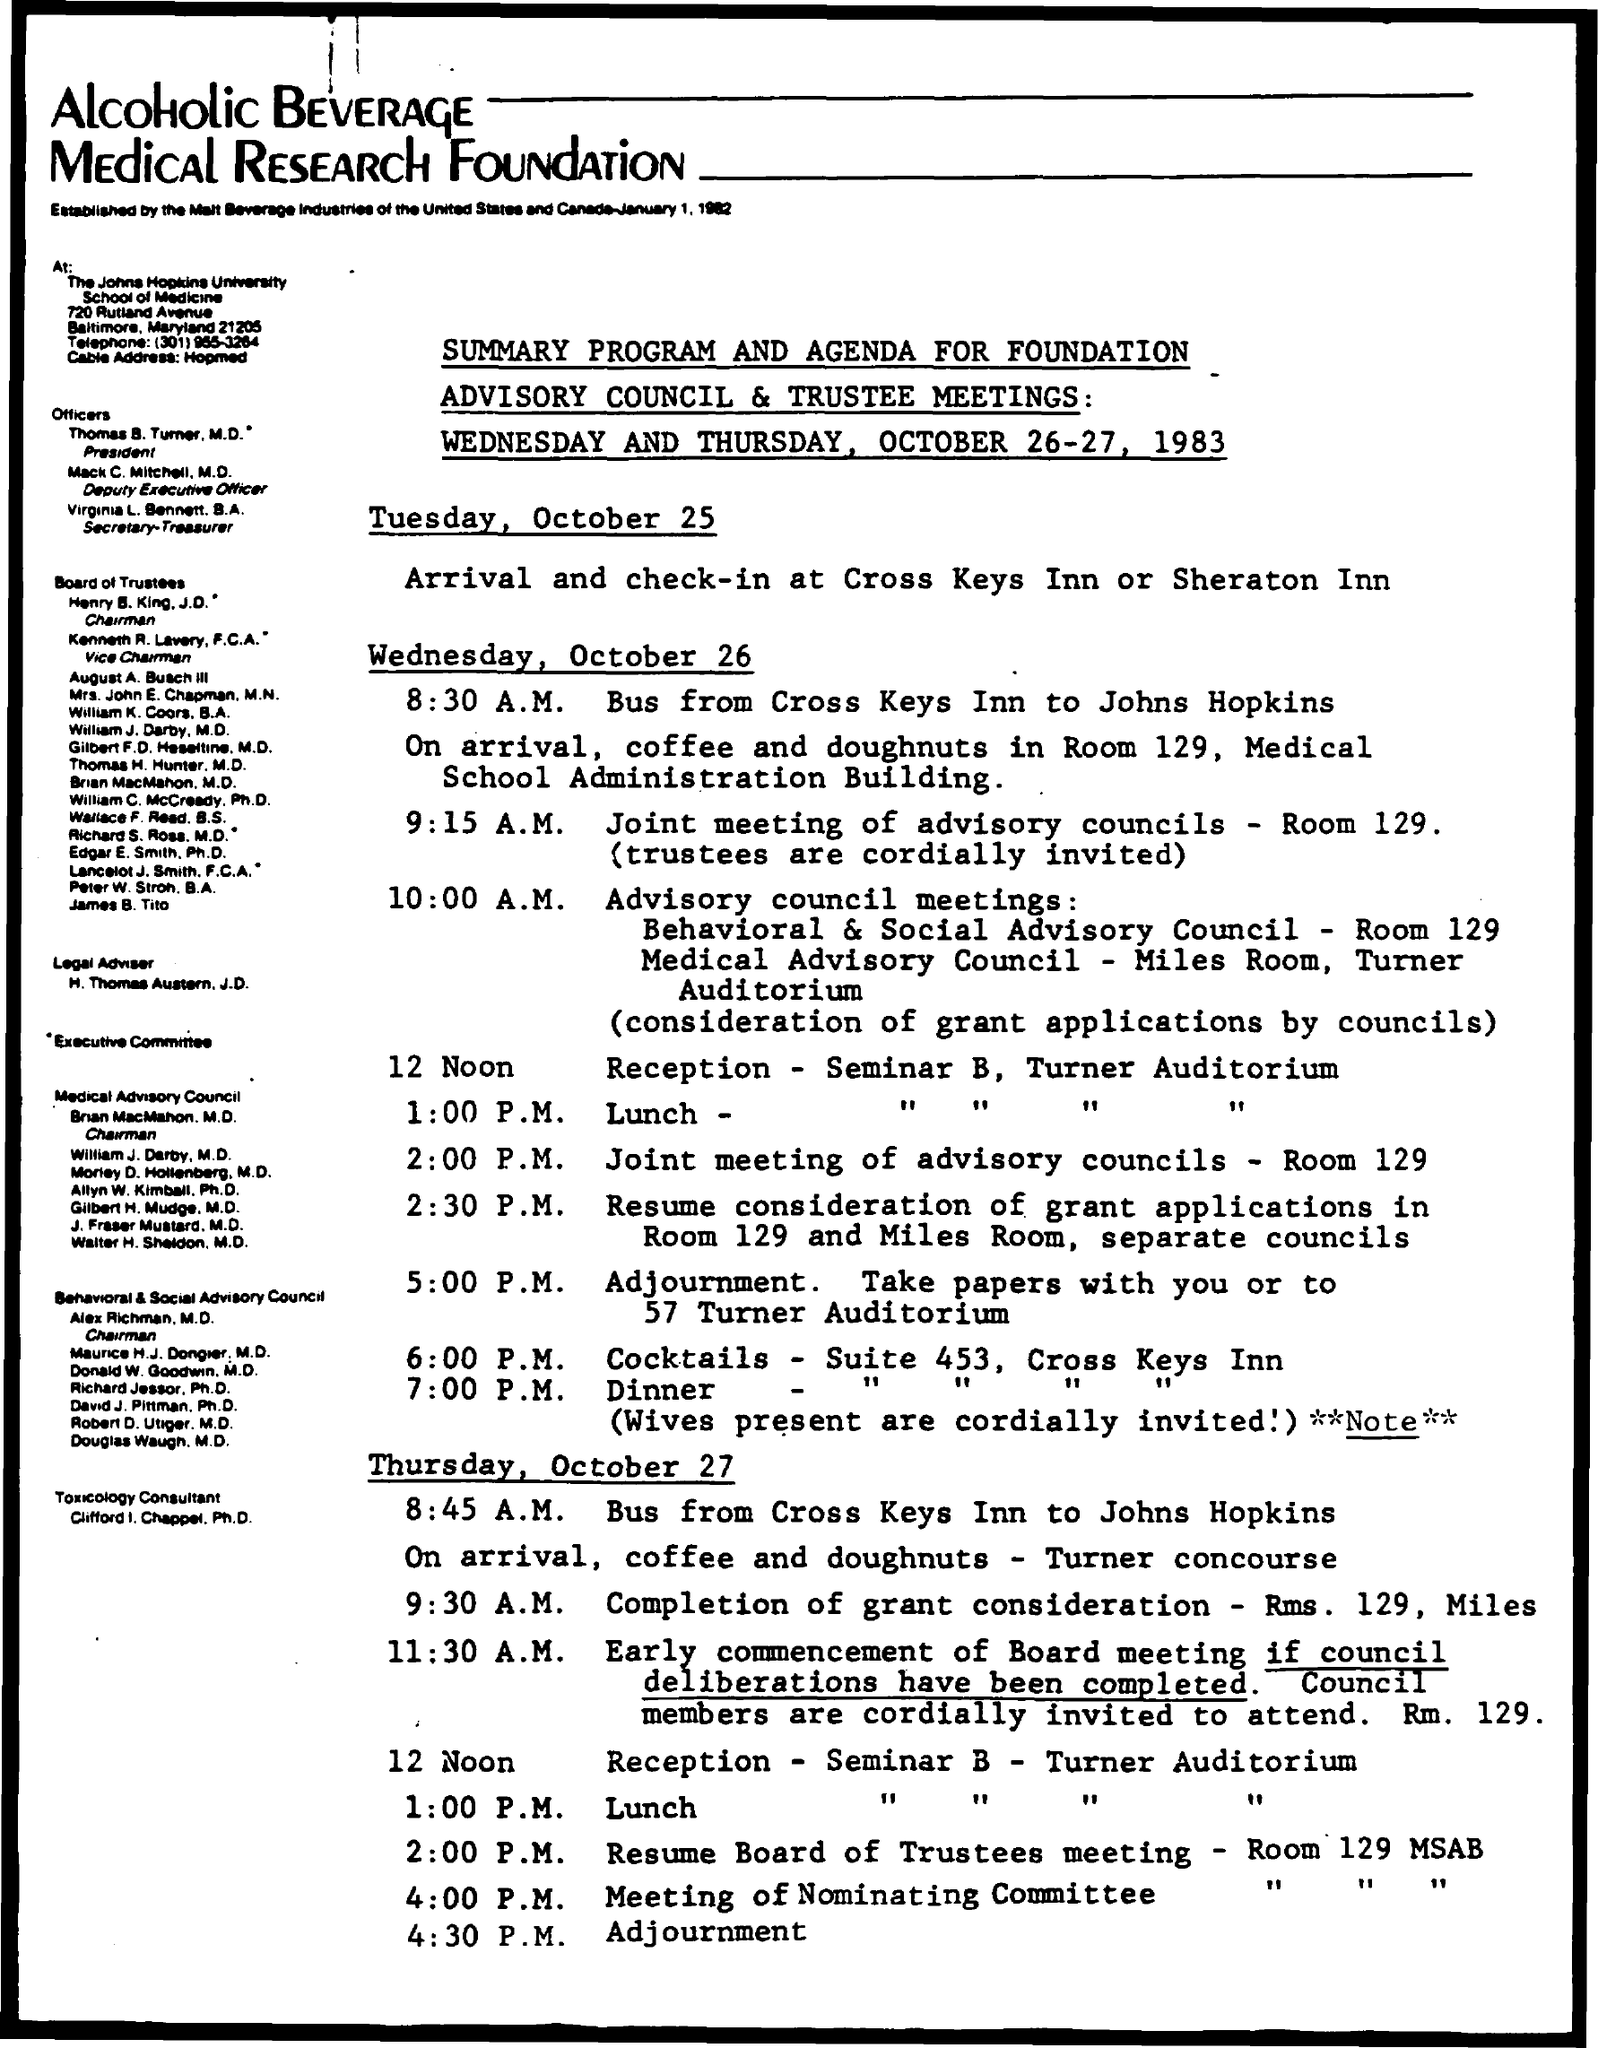Outline some significant characteristics in this image. The room number for the resume board of trustees meeting is Room 129 MSAB. It is currently 7:00 P.M. and time for dinner. The venue for arrival and check-in is either the Cross Keys Inn or the Sheraton Inn. The lunch time is 1:00 P.M. The time mentioned for cocktails is 6:00 P.M. 